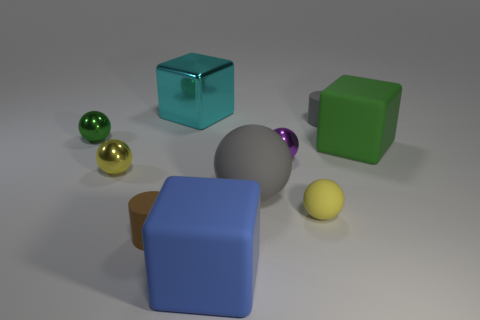Subtract all purple spheres. How many spheres are left? 4 Subtract all brown balls. Subtract all purple cylinders. How many balls are left? 5 Subtract all cylinders. How many objects are left? 8 Subtract 0 blue balls. How many objects are left? 10 Subtract all big purple shiny objects. Subtract all large blue matte cubes. How many objects are left? 9 Add 1 matte blocks. How many matte blocks are left? 3 Add 6 purple matte cylinders. How many purple matte cylinders exist? 6 